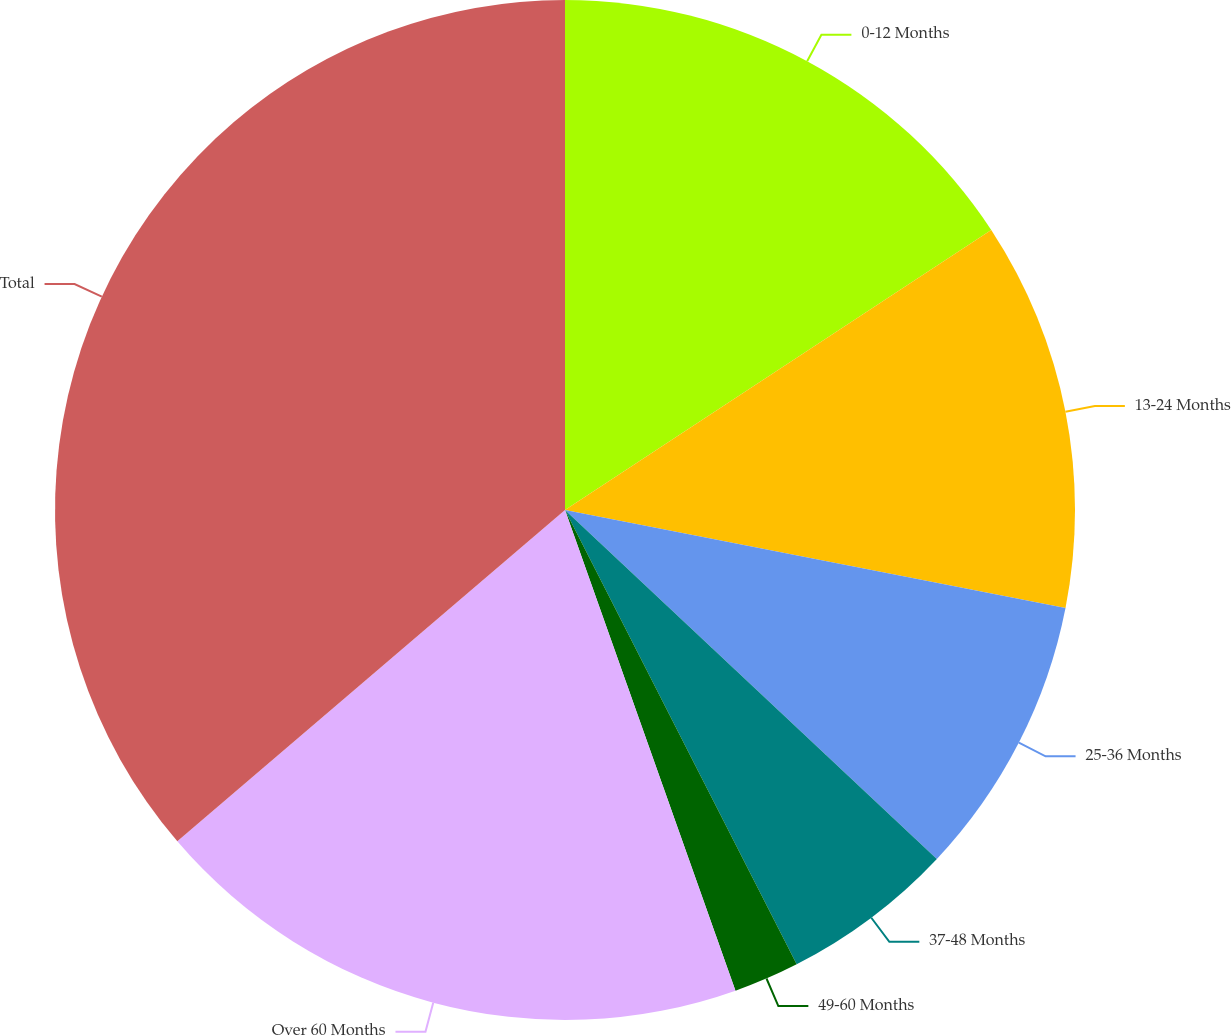Convert chart. <chart><loc_0><loc_0><loc_500><loc_500><pie_chart><fcel>0-12 Months<fcel>13-24 Months<fcel>25-36 Months<fcel>37-48 Months<fcel>49-60 Months<fcel>Over 60 Months<fcel>Total<nl><fcel>15.75%<fcel>12.33%<fcel>8.92%<fcel>5.5%<fcel>2.08%<fcel>19.17%<fcel>36.26%<nl></chart> 